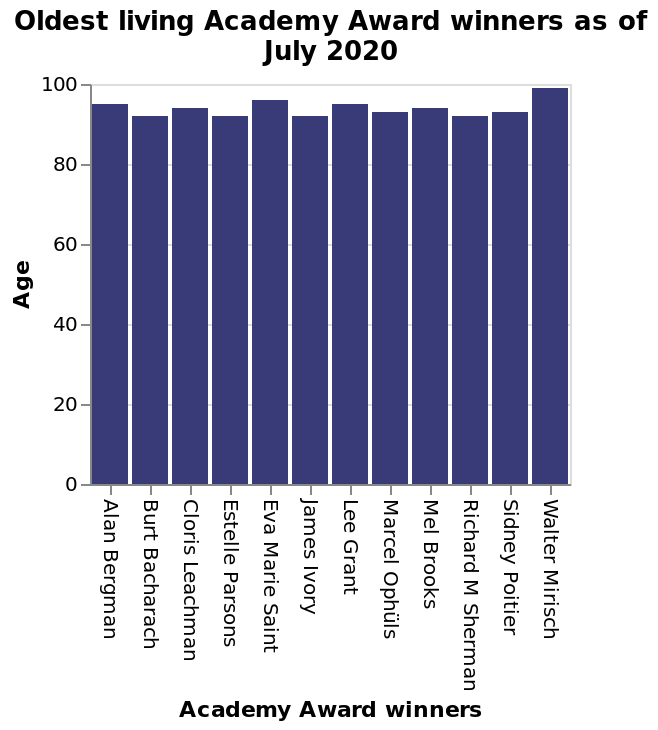<image>
What is the range of ages for the winners?  None of the winners are below 80, and the oldest winner is 100. please enumerates aspects of the construction of the chart This is a bar graph named Oldest living Academy Award winners as of July 2020. The x-axis measures Academy Award winners while the y-axis shows Age. 